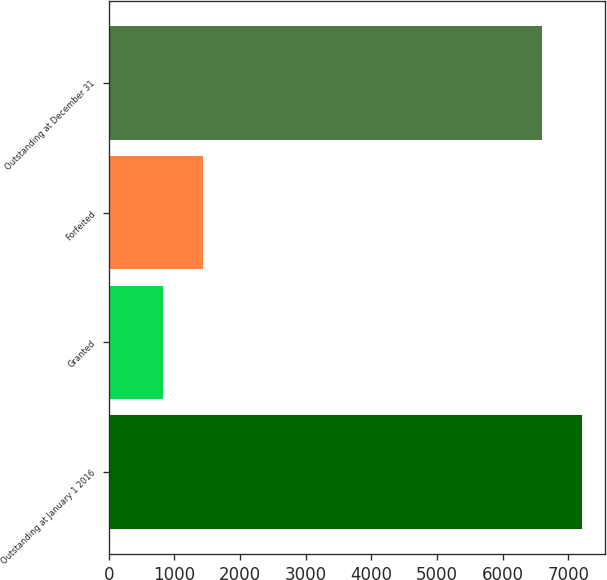Convert chart. <chart><loc_0><loc_0><loc_500><loc_500><bar_chart><fcel>Outstanding at January 1 2016<fcel>Granted<fcel>Forfeited<fcel>Outstanding at December 31<nl><fcel>7200.7<fcel>824<fcel>1432.7<fcel>6592<nl></chart> 